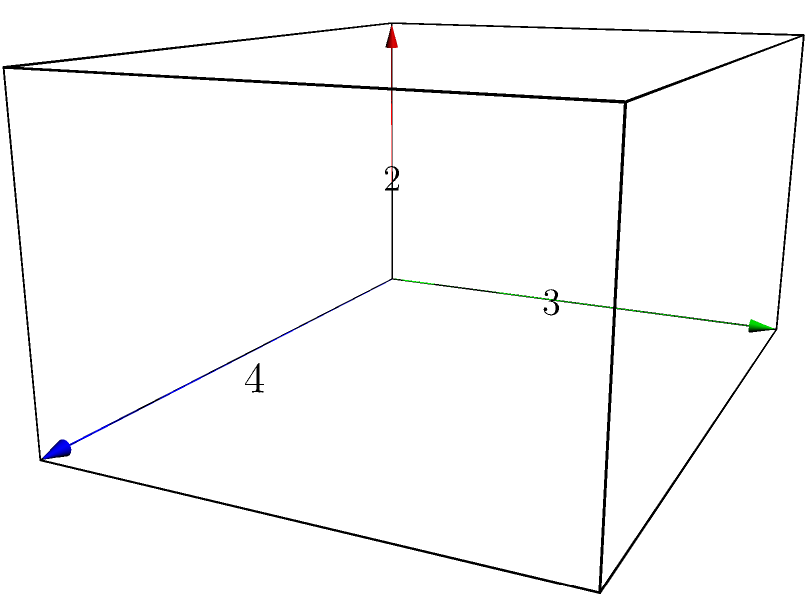Your study group is working on surface area problems. Given a rectangular prism with dimensions $4$ units in length, $3$ units in width, and $2$ units in height, what is its total surface area? Let's approach this step-by-step:

1) The surface area of a rectangular prism is the sum of the areas of all six faces.

2) We have three pairs of identical faces:
   - Two length-width faces (front and back)
   - Two length-height faces (top and bottom)
   - Two width-height faces (left and right)

3) Let's calculate the area of each pair:
   - Length-width faces: $4 \times 3 = 12$ square units each
   - Length-height faces: $4 \times 2 = 8$ square units each
   - Width-height faces: $3 \times 2 = 6$ square units each

4) Now, we sum up all the face areas:
   $$(2 \times 12) + (2 \times 8) + (2 \times 6)$$

5) Simplifying:
   $$24 + 16 + 12 = 52$$

Therefore, the total surface area of the rectangular prism is 52 square units.
Answer: $52$ square units 